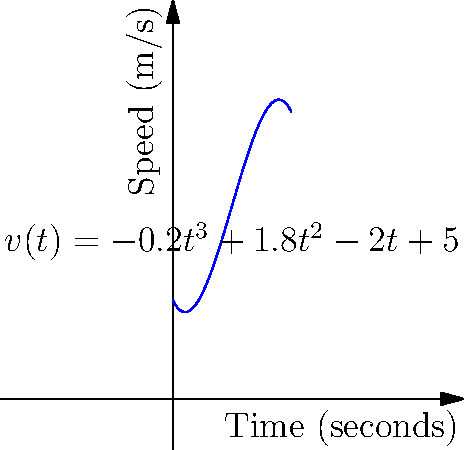As a sports commentator analyzing a runner's performance, you're given a function $v(t) = -0.2t^3 + 1.8t^2 - 2t + 5$ that represents the runner's speed (in m/s) over time (in seconds). At what time does the runner reach their maximum speed, and what is that maximum speed? To find the maximum speed, we need to follow these steps:

1) The maximum speed occurs where the derivative of $v(t)$ equals zero. Let's find $v'(t)$:

   $v'(t) = -0.6t^2 + 3.6t - 2$

2) Set $v'(t) = 0$ and solve for $t$:

   $-0.6t^2 + 3.6t - 2 = 0$

3) This is a quadratic equation. We can solve it using the quadratic formula:

   $t = \frac{-b \pm \sqrt{b^2 - 4ac}}{2a}$

   Where $a = -0.6$, $b = 3.6$, and $c = -2$

4) Plugging in these values:

   $t = \frac{-3.6 \pm \sqrt{3.6^2 - 4(-0.6)(-2)}}{2(-0.6)}$

   $= \frac{-3.6 \pm \sqrt{12.96 - 4.8}}{-1.2}$

   $= \frac{-3.6 \pm \sqrt{8.16}}{-1.2}$

   $= \frac{-3.6 \pm 2.86}{-1.2}$

5) This gives us two solutions:

   $t_1 = \frac{-3.6 + 2.86}{-1.2} \approx 0.62$ seconds
   $t_2 = \frac{-3.6 - 2.86}{-1.2} \approx 5.38$ seconds

6) To determine which one gives the maximum, we can check the second derivative:

   $v''(t) = -1.2t + 3.6$

   At $t = 0.62$: $v''(0.62) = -1.2(0.62) + 3.6 \approx 2.86$ (positive, so it's a minimum)
   At $t = 5.38$: $v''(5.38) = -1.2(5.38) + 3.6 \approx -2.86$ (negative, so it's a maximum)

7) Therefore, the maximum speed occurs at $t \approx 5.38$ seconds.

8) To find the maximum speed, we plug this time back into the original function:

   $v(5.38) = -0.2(5.38)^3 + 1.8(5.38)^2 - 2(5.38) + 5 \approx 9.16$ m/s

Thus, the runner reaches their maximum speed of approximately 9.16 m/s at about 5.38 seconds.
Answer: Maximum speed of 9.16 m/s at 5.38 seconds 